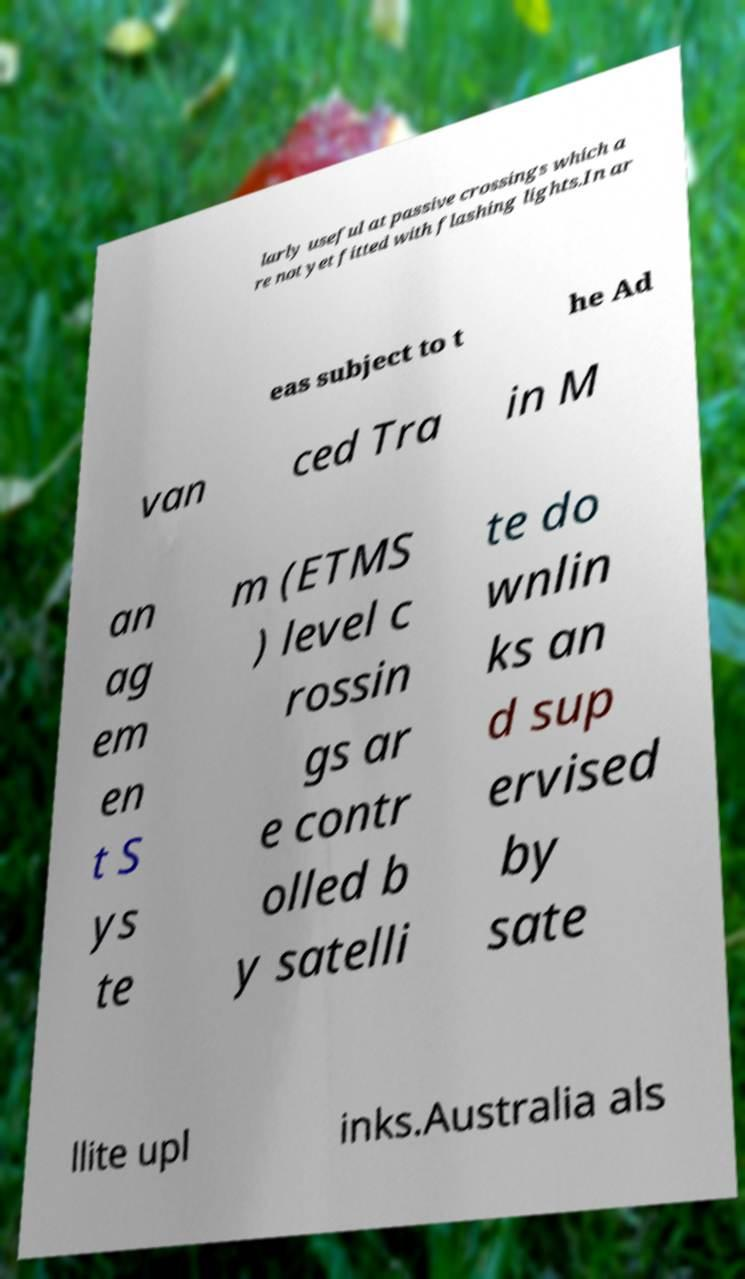Can you accurately transcribe the text from the provided image for me? larly useful at passive crossings which a re not yet fitted with flashing lights.In ar eas subject to t he Ad van ced Tra in M an ag em en t S ys te m (ETMS ) level c rossin gs ar e contr olled b y satelli te do wnlin ks an d sup ervised by sate llite upl inks.Australia als 